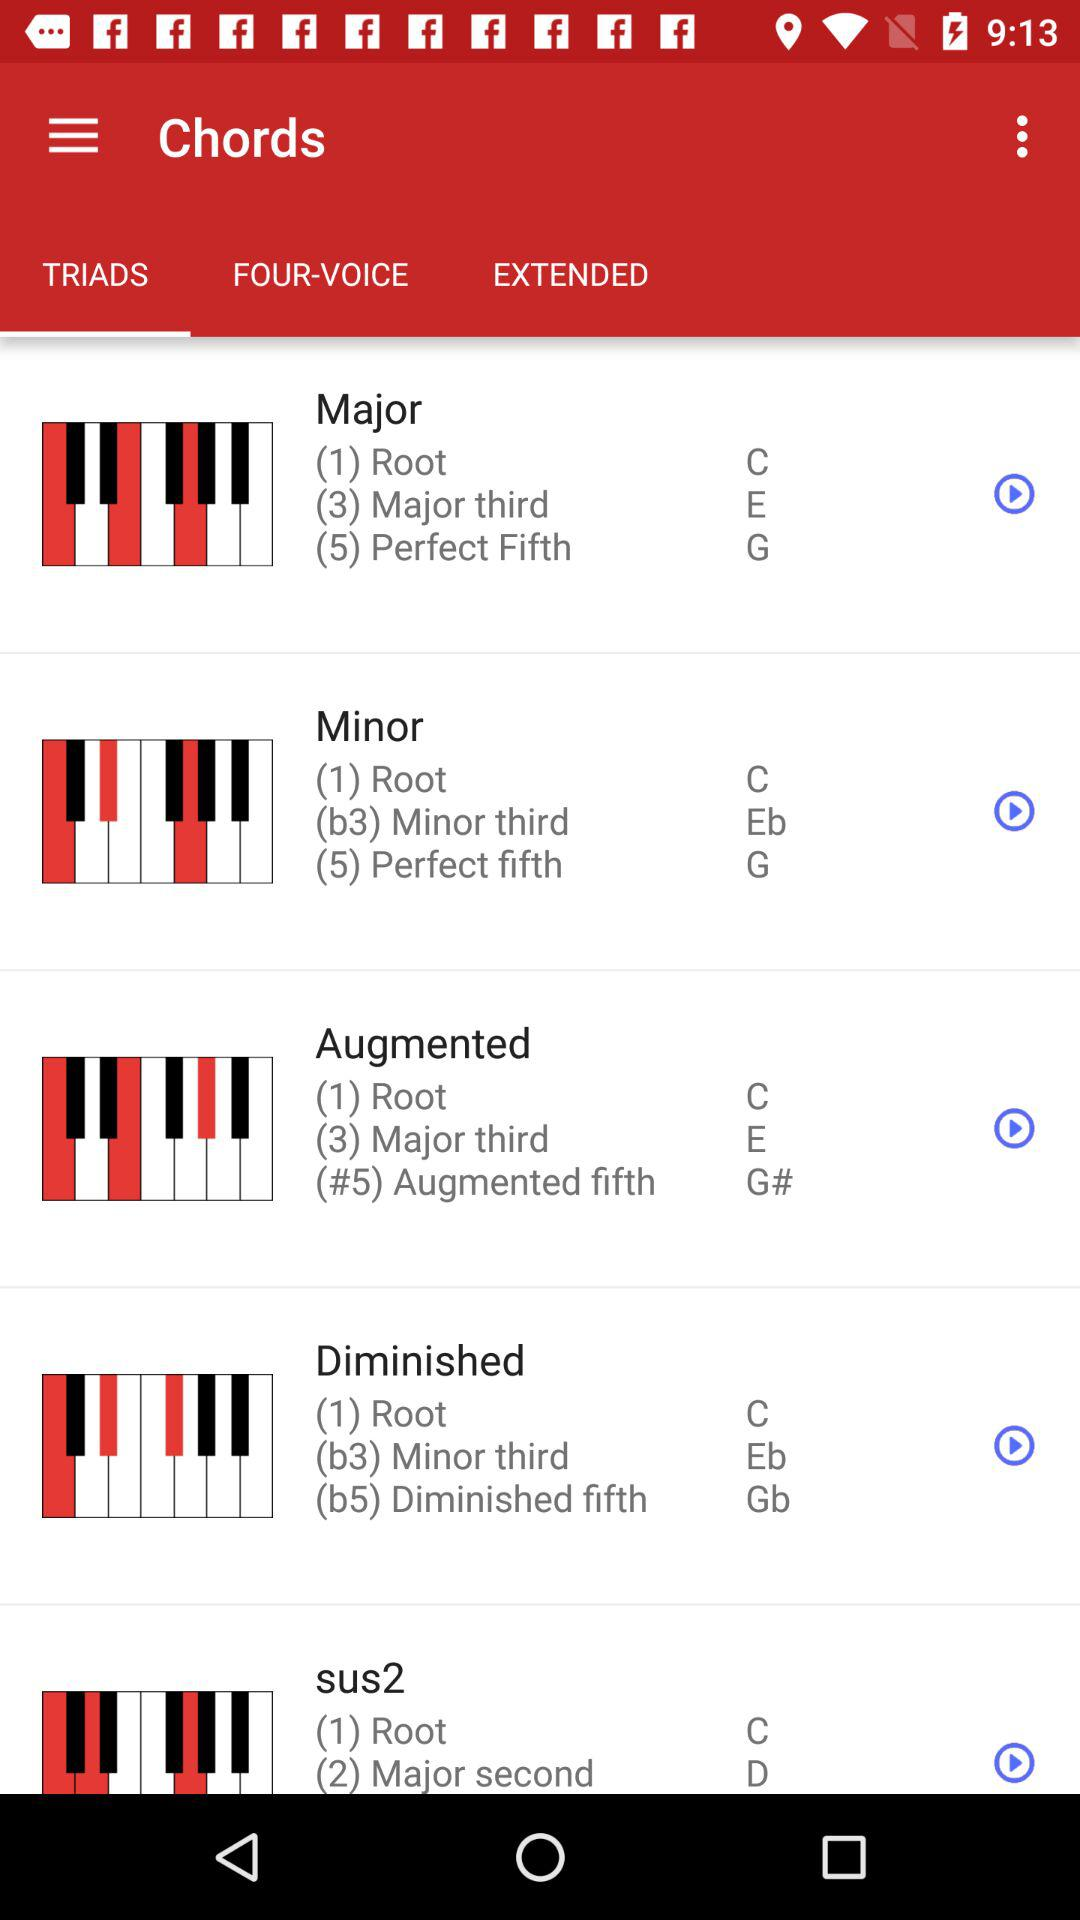What is the selected tab? The selected tab is "TRIADS". 